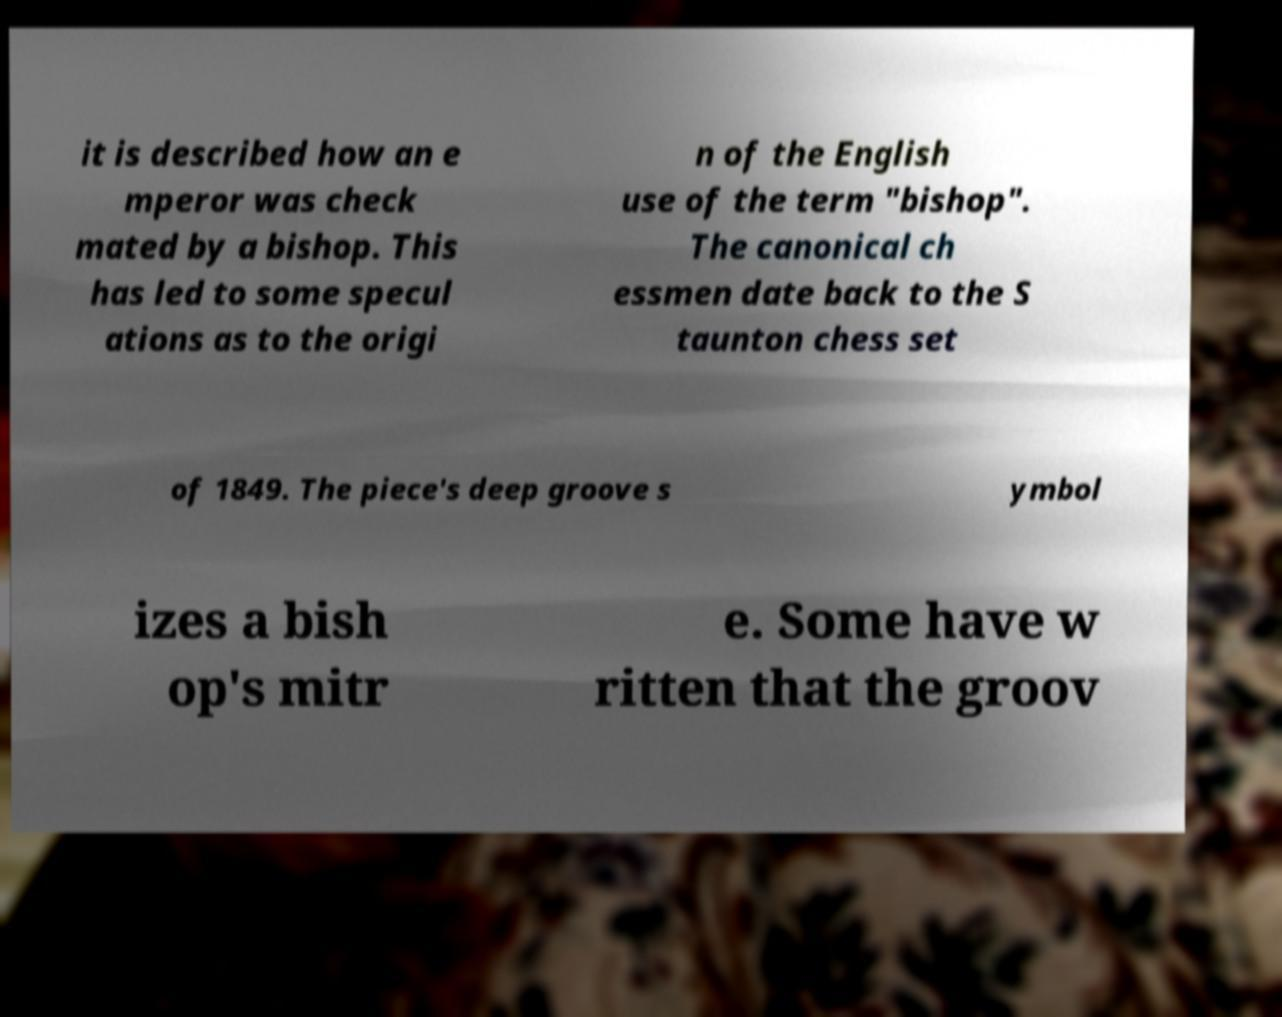Can you read and provide the text displayed in the image?This photo seems to have some interesting text. Can you extract and type it out for me? it is described how an e mperor was check mated by a bishop. This has led to some specul ations as to the origi n of the English use of the term "bishop". The canonical ch essmen date back to the S taunton chess set of 1849. The piece's deep groove s ymbol izes a bish op's mitr e. Some have w ritten that the groov 